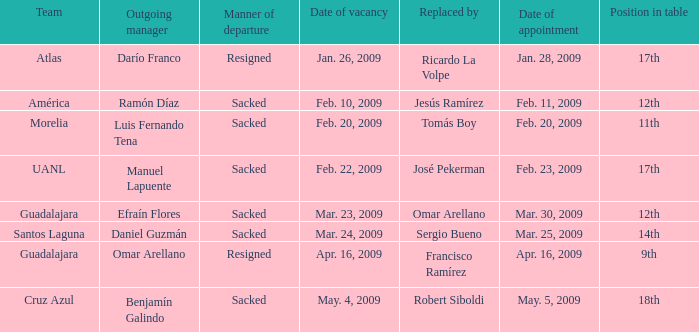What is Team, when Replaced By is "Jesús Ramírez"? América. 